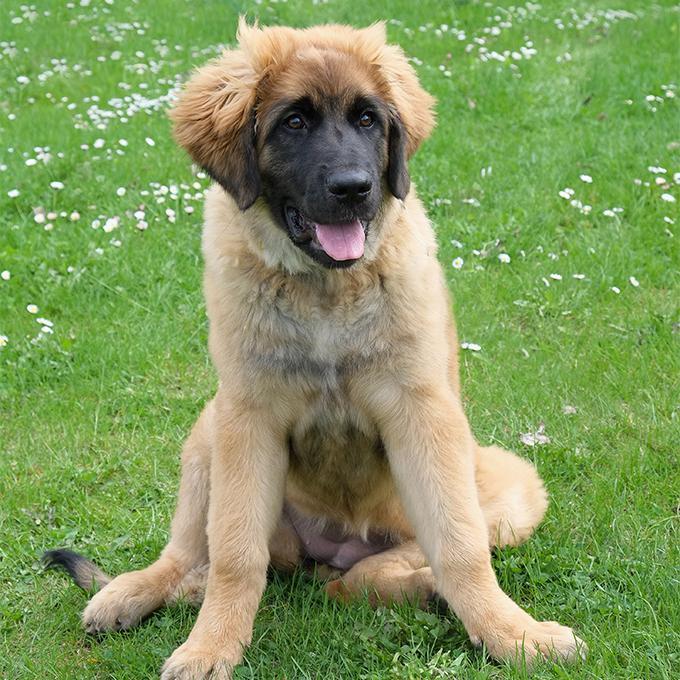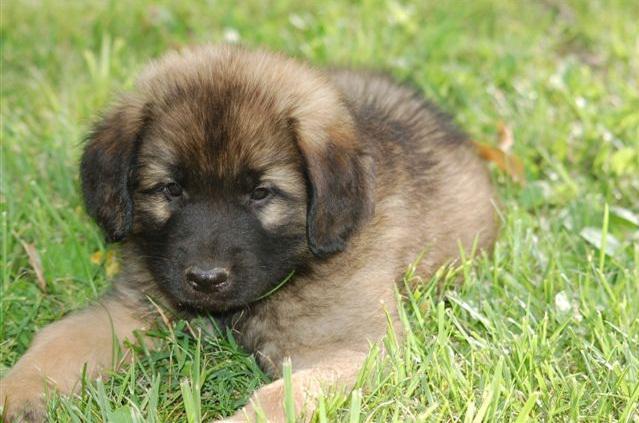The first image is the image on the left, the second image is the image on the right. Considering the images on both sides, is "The right image contains at least four dogs." valid? Answer yes or no. No. The first image is the image on the left, the second image is the image on the right. Evaluate the accuracy of this statement regarding the images: "One dog is on the back of another dog, and the image contains no more than five dogs.". Is it true? Answer yes or no. No. 